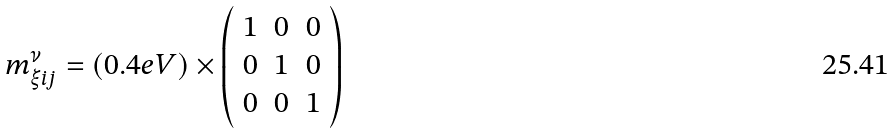<formula> <loc_0><loc_0><loc_500><loc_500>m _ { \xi i j } ^ { \nu } = ( 0 . 4 e V ) \times \left ( \begin{array} { l l l } { 1 } & { 0 } & { 0 } \\ { 0 } & { 1 } & { 0 } \\ { 0 } & { 0 } & { 1 } \end{array} \right )</formula> 